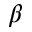Convert formula to latex. <formula><loc_0><loc_0><loc_500><loc_500>_ { \beta }</formula> 